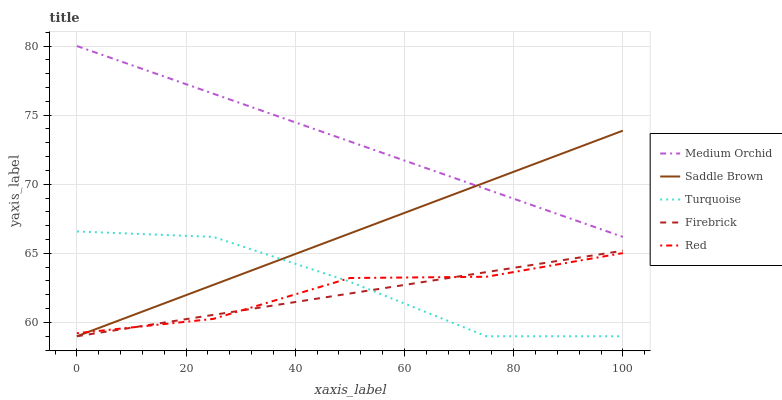Does Firebrick have the minimum area under the curve?
Answer yes or no. Yes. Does Medium Orchid have the maximum area under the curve?
Answer yes or no. Yes. Does Turquoise have the minimum area under the curve?
Answer yes or no. No. Does Turquoise have the maximum area under the curve?
Answer yes or no. No. Is Medium Orchid the smoothest?
Answer yes or no. Yes. Is Turquoise the roughest?
Answer yes or no. Yes. Is Turquoise the smoothest?
Answer yes or no. No. Is Medium Orchid the roughest?
Answer yes or no. No. Does Firebrick have the lowest value?
Answer yes or no. Yes. Does Medium Orchid have the lowest value?
Answer yes or no. No. Does Medium Orchid have the highest value?
Answer yes or no. Yes. Does Turquoise have the highest value?
Answer yes or no. No. Is Red less than Medium Orchid?
Answer yes or no. Yes. Is Medium Orchid greater than Turquoise?
Answer yes or no. Yes. Does Saddle Brown intersect Firebrick?
Answer yes or no. Yes. Is Saddle Brown less than Firebrick?
Answer yes or no. No. Is Saddle Brown greater than Firebrick?
Answer yes or no. No. Does Red intersect Medium Orchid?
Answer yes or no. No. 